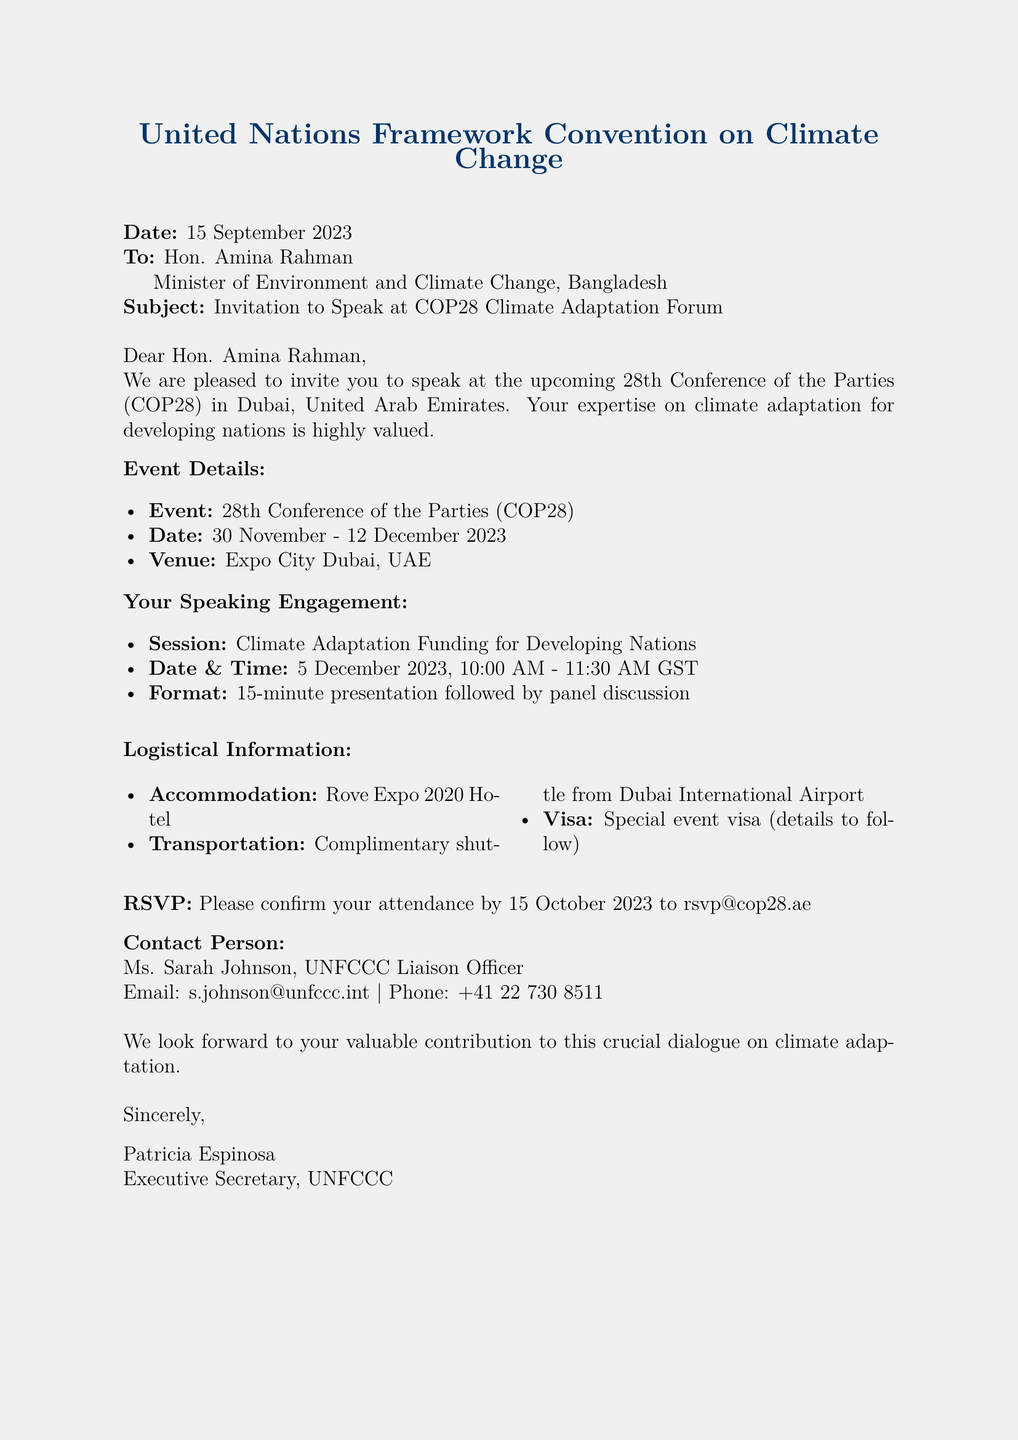What is the date of the event? The date of the event is mentioned in the document as 30 November - 12 December 2023.
Answer: 30 November - 12 December 2023 Who is the contact person for this invitation? The document specifies Ms. Sarah Johnson as the contact person for the invitation.
Answer: Ms. Sarah Johnson What is the venue for COP28? The venue for COP28 is mentioned in the document as Expo City Dubai, UAE.
Answer: Expo City Dubai, UAE What is the date and time of the speaking engagement? The date and time of the speaking engagement is provided as 5 December 2023, 10:00 AM - 11:30 AM GST.
Answer: 5 December 2023, 10:00 AM - 11:30 AM GST What type of visa will be provided? The document states a special event visa will be provided.
Answer: Special event visa How long is the presentation during the engagement? The document indicates that the presentation will be for 15 minutes.
Answer: 15 minutes When should the RSVP be confirmed by? The document specifies that the RSVP should be confirmed by 15 October 2023.
Answer: 15 October 2023 What hotel will accommodate the speaker? The document lists Rove Expo 2020 Hotel as the accommodation for the speaker.
Answer: Rove Expo 2020 Hotel What is the email to confirm attendance? The document provides rsvp@cop28.ae as the email to confirm attendance.
Answer: rsvp@cop28.ae 